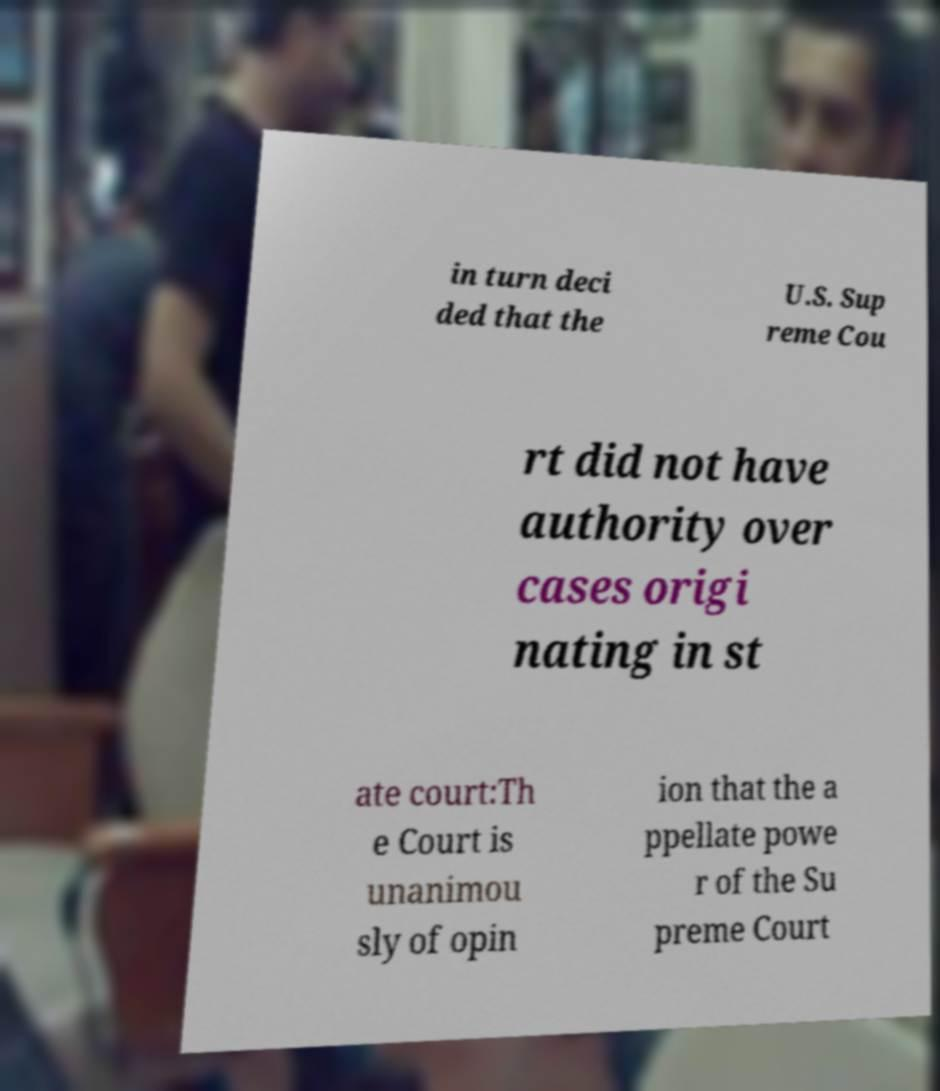Can you read and provide the text displayed in the image?This photo seems to have some interesting text. Can you extract and type it out for me? in turn deci ded that the U.S. Sup reme Cou rt did not have authority over cases origi nating in st ate court:Th e Court is unanimou sly of opin ion that the a ppellate powe r of the Su preme Court 